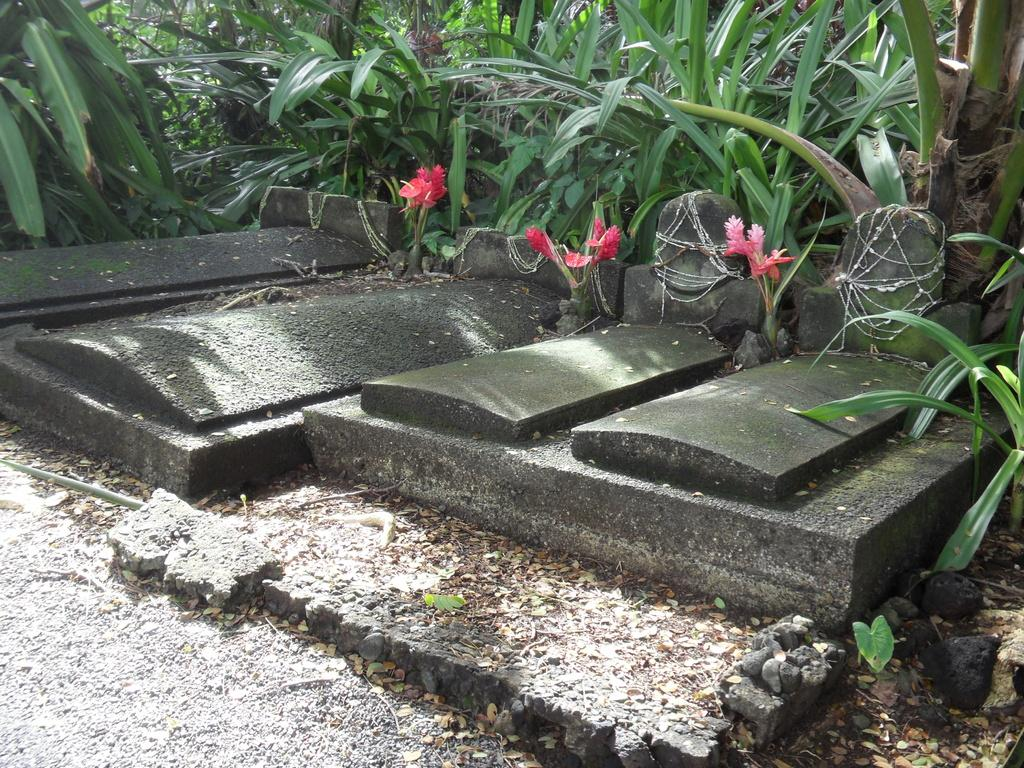What type of structures can be seen in the image? There are graves in the image. What other elements can be found in the image? There are plants, flowers, and rocks present in the image. What type of creature is standing near the graves in the image? There is no creature present in the image; it only features graves, plants, flowers, and rocks. 